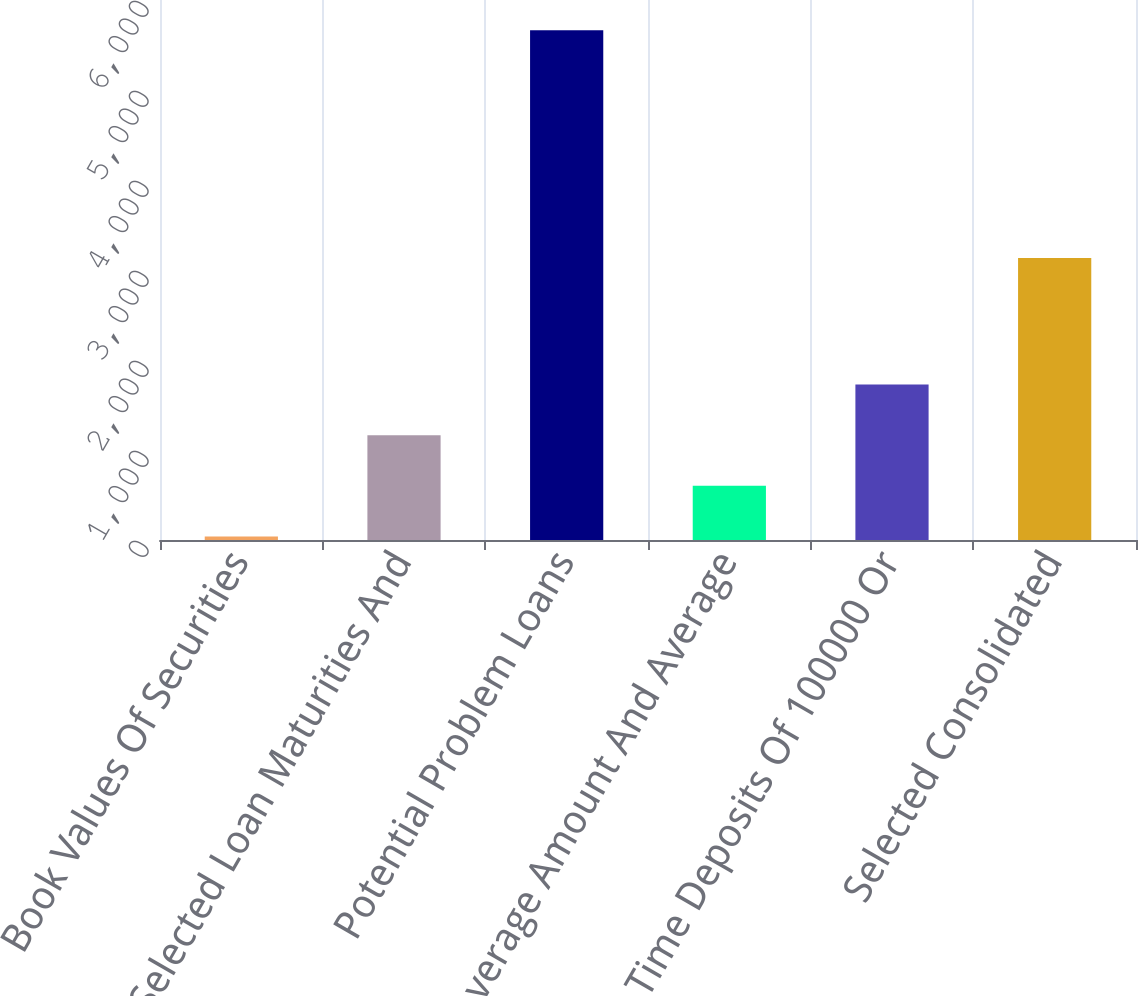<chart> <loc_0><loc_0><loc_500><loc_500><bar_chart><fcel>Book Values Of Securities<fcel>Selected Loan Maturities And<fcel>Potential Problem Loans<fcel>Average Amount And Average<fcel>Time Deposits Of 100000 Or<fcel>Selected Consolidated<nl><fcel>40<fcel>1164.8<fcel>5664<fcel>602.4<fcel>1727.2<fcel>3132<nl></chart> 